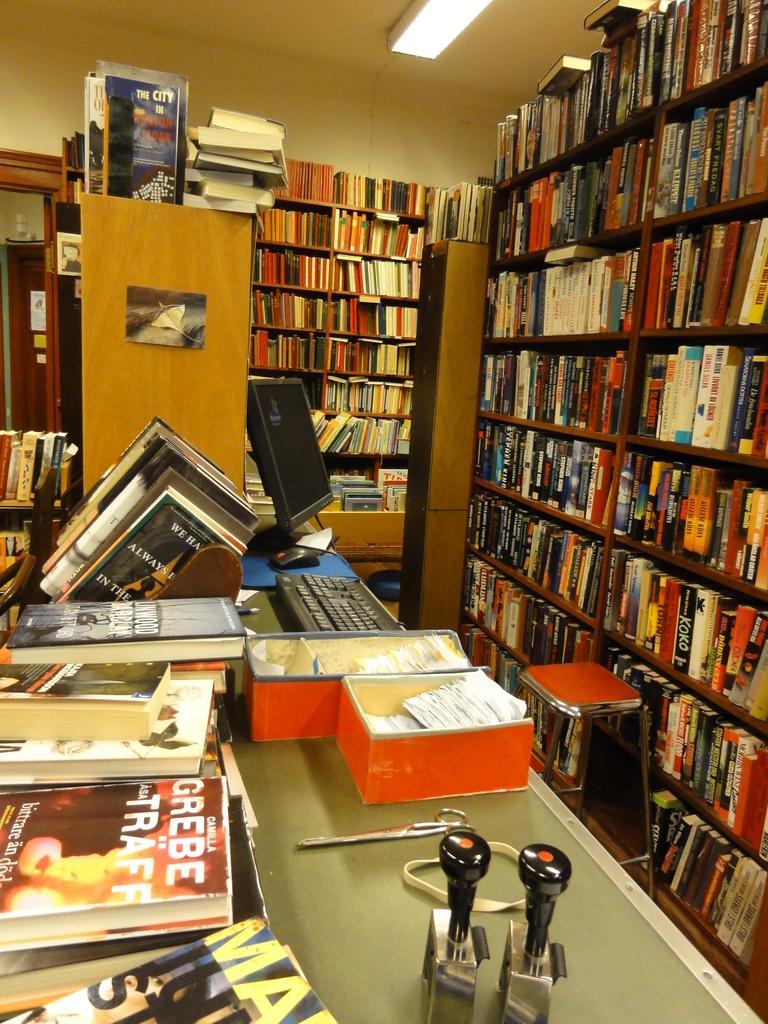Please provide a concise description of this image. This picture might be taken in a library, in this image there are some book racks. In that book racks there are some books, and at the bottom there is one table. On the table there is one keyboard, computer, books, scissor and boxes and some other objects. And on the right side there is one stool, on the left side there is a door. At the top there is ceiling and light. 